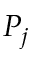Convert formula to latex. <formula><loc_0><loc_0><loc_500><loc_500>P _ { j }</formula> 